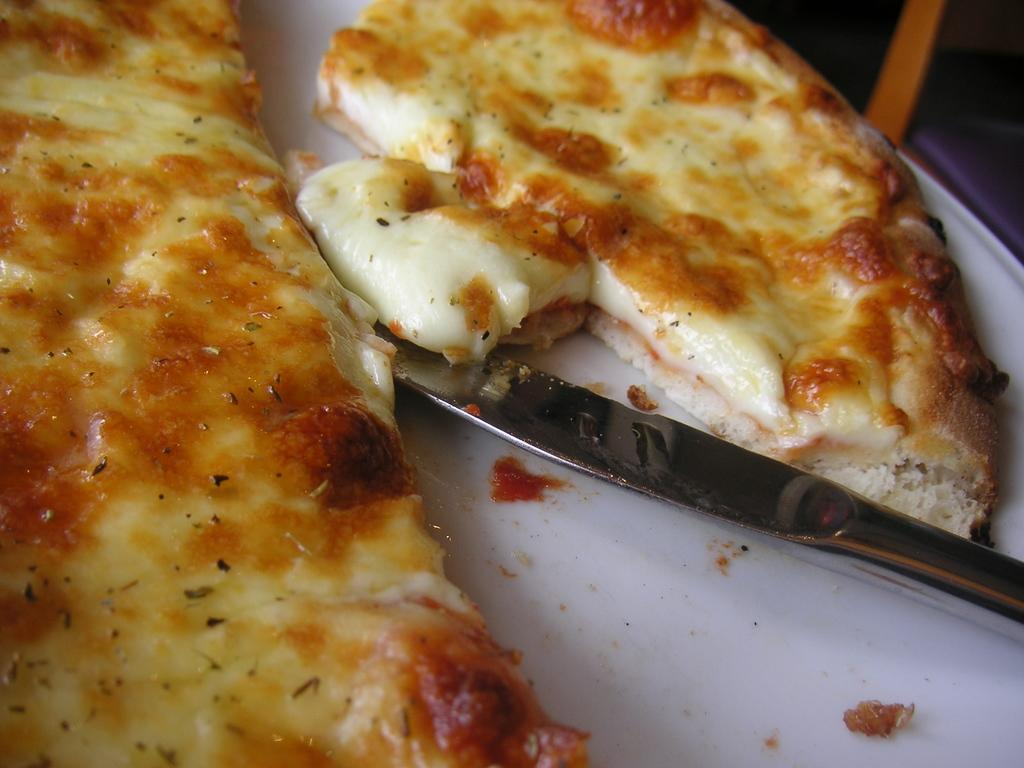What type of food can be seen in the foreground of the image? There are pieces of pizza in the foreground of the image. What utensil is present on a platter in the foreground of the image? There is a knife on a platter in the foreground of the image. Can you describe the objects in the top right corner of the image? The objects in the top right corner of the image are unclear and cannot be definitively described. What type of legal advice is the lawyer providing to the giants in the image? There is no lawyer or giants present in the image; it features pieces of pizza and a knife on a platter. What type of cream is being used to decorate the pizza in the image? There is no cream visible on the pizza in the image. 